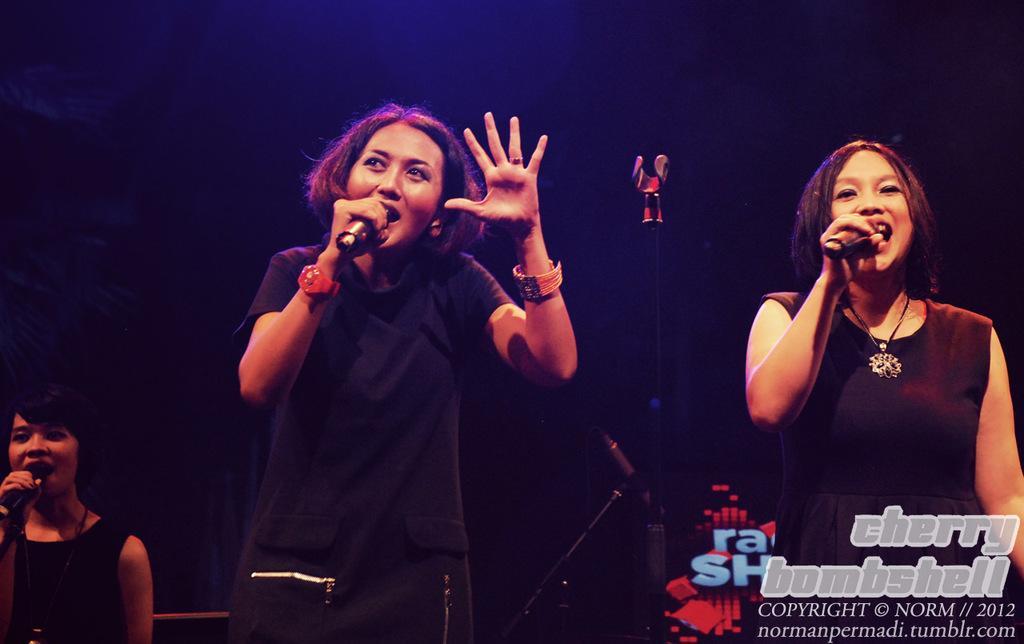How would you summarize this image in a sentence or two? In this image I can see three women are standing and I can see all of them are holding mics. Here I can see all of them are wearing black dress. 